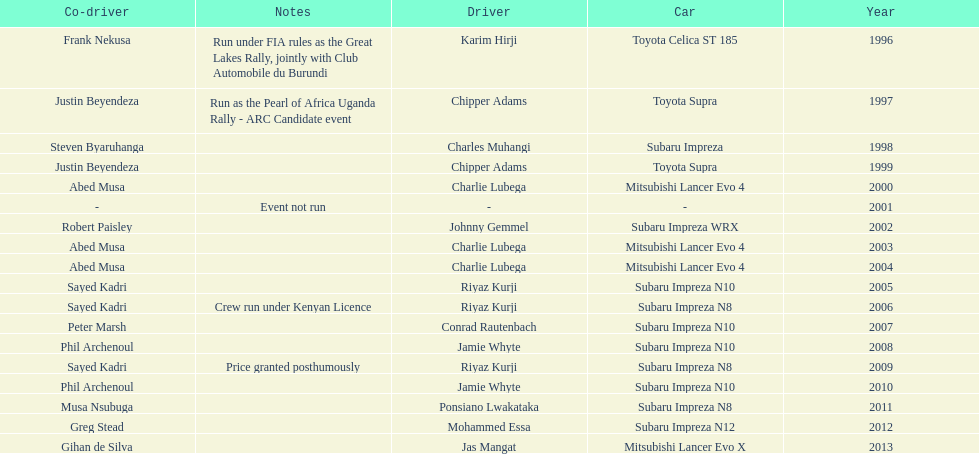Help me parse the entirety of this table. {'header': ['Co-driver', 'Notes', 'Driver', 'Car', 'Year'], 'rows': [['Frank Nekusa', 'Run under FIA rules as the Great Lakes Rally, jointly with Club Automobile du Burundi', 'Karim Hirji', 'Toyota Celica ST 185', '1996'], ['Justin Beyendeza', 'Run as the Pearl of Africa Uganda Rally - ARC Candidate event', 'Chipper Adams', 'Toyota Supra', '1997'], ['Steven Byaruhanga', '', 'Charles Muhangi', 'Subaru Impreza', '1998'], ['Justin Beyendeza', '', 'Chipper Adams', 'Toyota Supra', '1999'], ['Abed Musa', '', 'Charlie Lubega', 'Mitsubishi Lancer Evo 4', '2000'], ['-', 'Event not run', '-', '-', '2001'], ['Robert Paisley', '', 'Johnny Gemmel', 'Subaru Impreza WRX', '2002'], ['Abed Musa', '', 'Charlie Lubega', 'Mitsubishi Lancer Evo 4', '2003'], ['Abed Musa', '', 'Charlie Lubega', 'Mitsubishi Lancer Evo 4', '2004'], ['Sayed Kadri', '', 'Riyaz Kurji', 'Subaru Impreza N10', '2005'], ['Sayed Kadri', 'Crew run under Kenyan Licence', 'Riyaz Kurji', 'Subaru Impreza N8', '2006'], ['Peter Marsh', '', 'Conrad Rautenbach', 'Subaru Impreza N10', '2007'], ['Phil Archenoul', '', 'Jamie Whyte', 'Subaru Impreza N10', '2008'], ['Sayed Kadri', 'Price granted posthumously', 'Riyaz Kurji', 'Subaru Impreza N8', '2009'], ['Phil Archenoul', '', 'Jamie Whyte', 'Subaru Impreza N10', '2010'], ['Musa Nsubuga', '', 'Ponsiano Lwakataka', 'Subaru Impreza N8', '2011'], ['Greg Stead', '', 'Mohammed Essa', 'Subaru Impreza N12', '2012'], ['Gihan de Silva', '', 'Jas Mangat', 'Mitsubishi Lancer Evo X', '2013']]} How many drivers are racing with a co-driver from a different country? 1. 